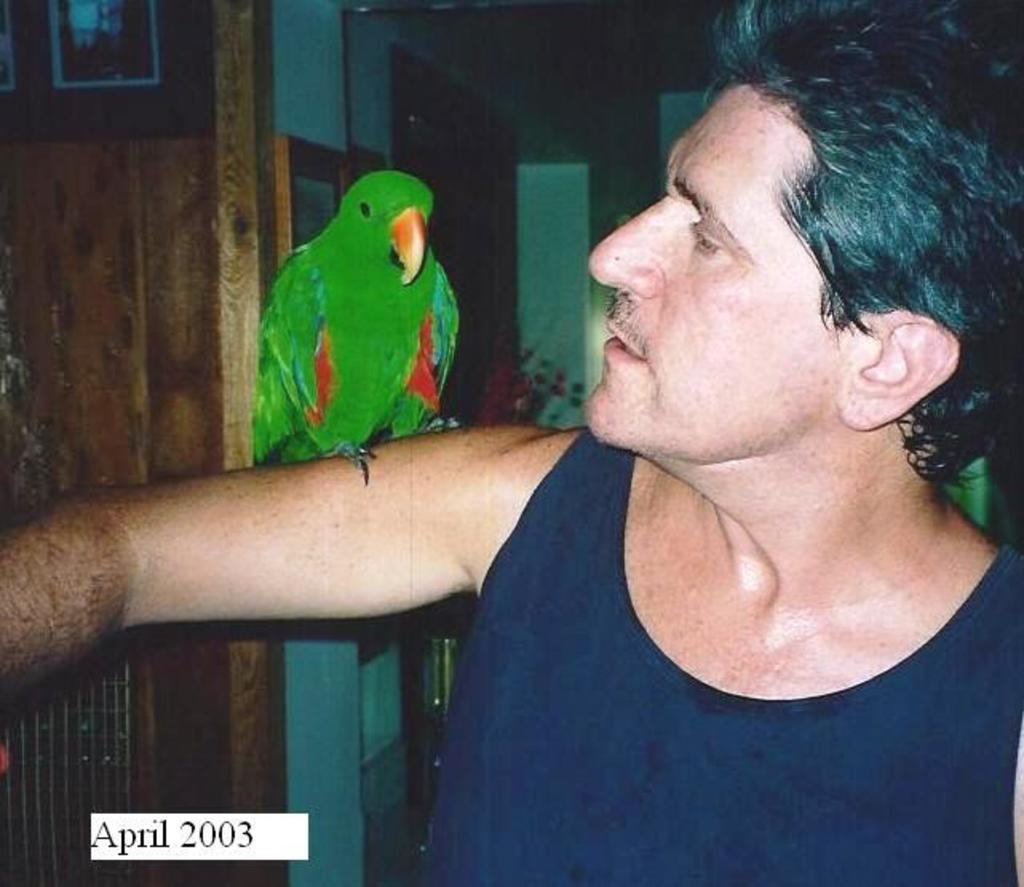Could you give a brief overview of what you see in this image? Here we can see a parrot on the hand of a person. In the background we can see frames and wall. 